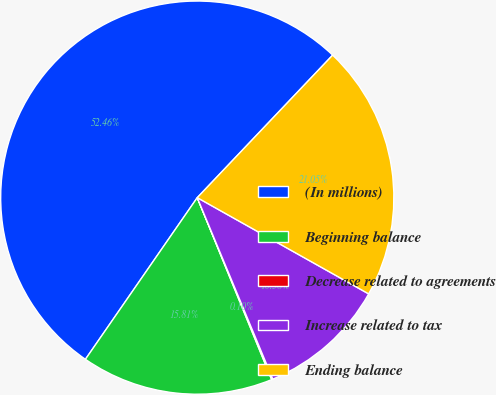Convert chart. <chart><loc_0><loc_0><loc_500><loc_500><pie_chart><fcel>(In millions)<fcel>Beginning balance<fcel>Decrease related to agreements<fcel>Increase related to tax<fcel>Ending balance<nl><fcel>52.46%<fcel>15.81%<fcel>0.1%<fcel>10.58%<fcel>21.05%<nl></chart> 